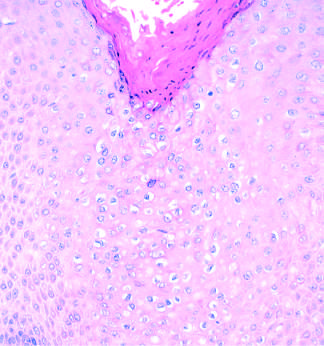do the chromatin texture, with fine and coarse clumps, include acanthosis, hyperkeratosis, and cytoplasmic vacuolization?
Answer the question using a single word or phrase. No 